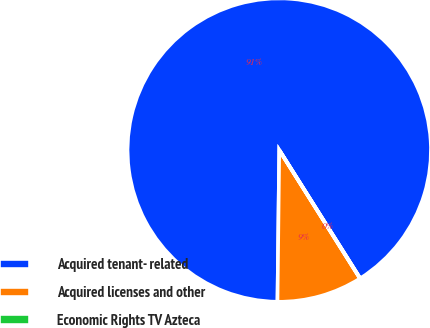Convert chart to OTSL. <chart><loc_0><loc_0><loc_500><loc_500><pie_chart><fcel>Acquired tenant- related<fcel>Acquired licenses and other<fcel>Economic Rights TV Azteca<nl><fcel>90.85%<fcel>9.12%<fcel>0.03%<nl></chart> 